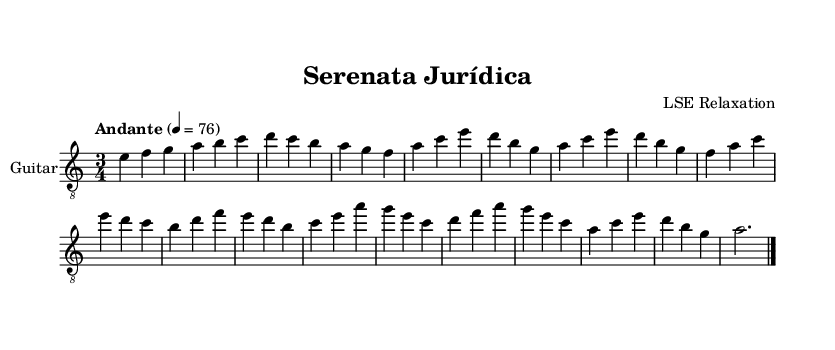What is the key signature of this music? The key signature is A minor, which is indicated by the absence of sharps or flats on the staff. A minor is the relative minor of C major.
Answer: A minor What is the time signature of the piece? The time signature is indicated at the beginning of the score as 3/4, which means there are three beats in each measure and a quarter note receives one beat.
Answer: 3/4 What is the tempo marking for this piece? The tempo marking is indicated as Andante, which suggests a moderately slow tempo, typically around 76 beats per minute. Additionally, an exact metronome marking of 4 = 76 is provided, specifying the beats per minute more precisely.
Answer: Andante How many measures are in the section labeled "A"? The section labeled "A" contains four measures, as specified in the group of notes that follows the indication 'A' in the score. Each measure is separated by a vertical line.
Answer: 4 What are the first three notes of the piece? The first three notes of the piece, found in the intro, are E, F, and G. These notes appear in the first measure and are read sequentially from left to right.
Answer: E, F, G What instruments are notated in the score? The only instrument notated in the score is the "Guitar," as indicated by the instrument name at the top of the staff. The term "Guitar" specifies that the part is written for the acoustic guitar specifically.
Answer: Guitar 